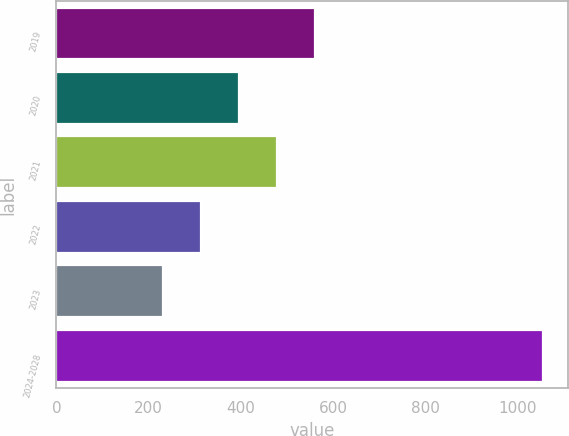Convert chart to OTSL. <chart><loc_0><loc_0><loc_500><loc_500><bar_chart><fcel>2019<fcel>2020<fcel>2021<fcel>2022<fcel>2023<fcel>2024-2028<nl><fcel>560.6<fcel>395.8<fcel>478.2<fcel>313.4<fcel>231<fcel>1055<nl></chart> 